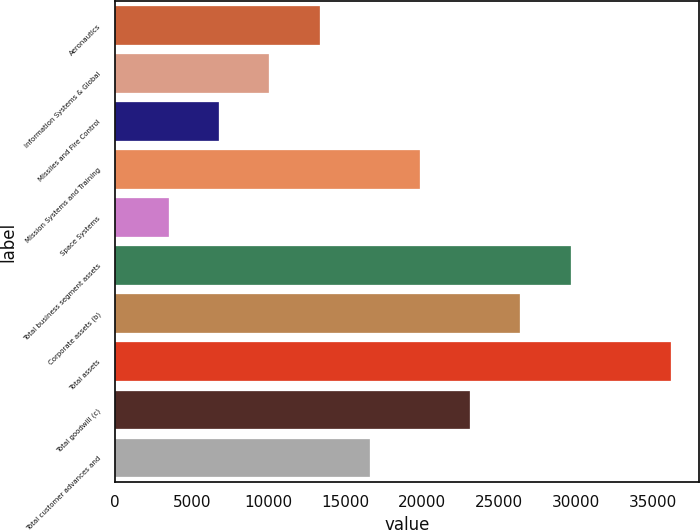<chart> <loc_0><loc_0><loc_500><loc_500><bar_chart><fcel>Aeronautics<fcel>Information Systems & Global<fcel>Missiles and Fire Control<fcel>Mission Systems and Training<fcel>Space Systems<fcel>Total business segment assets<fcel>Corporate assets (b)<fcel>Total assets<fcel>Total goodwill (c)<fcel>Total customer advances and<nl><fcel>13321.8<fcel>10055.2<fcel>6788.6<fcel>19855<fcel>3522<fcel>29654.8<fcel>26388.2<fcel>36188<fcel>23121.6<fcel>16588.4<nl></chart> 